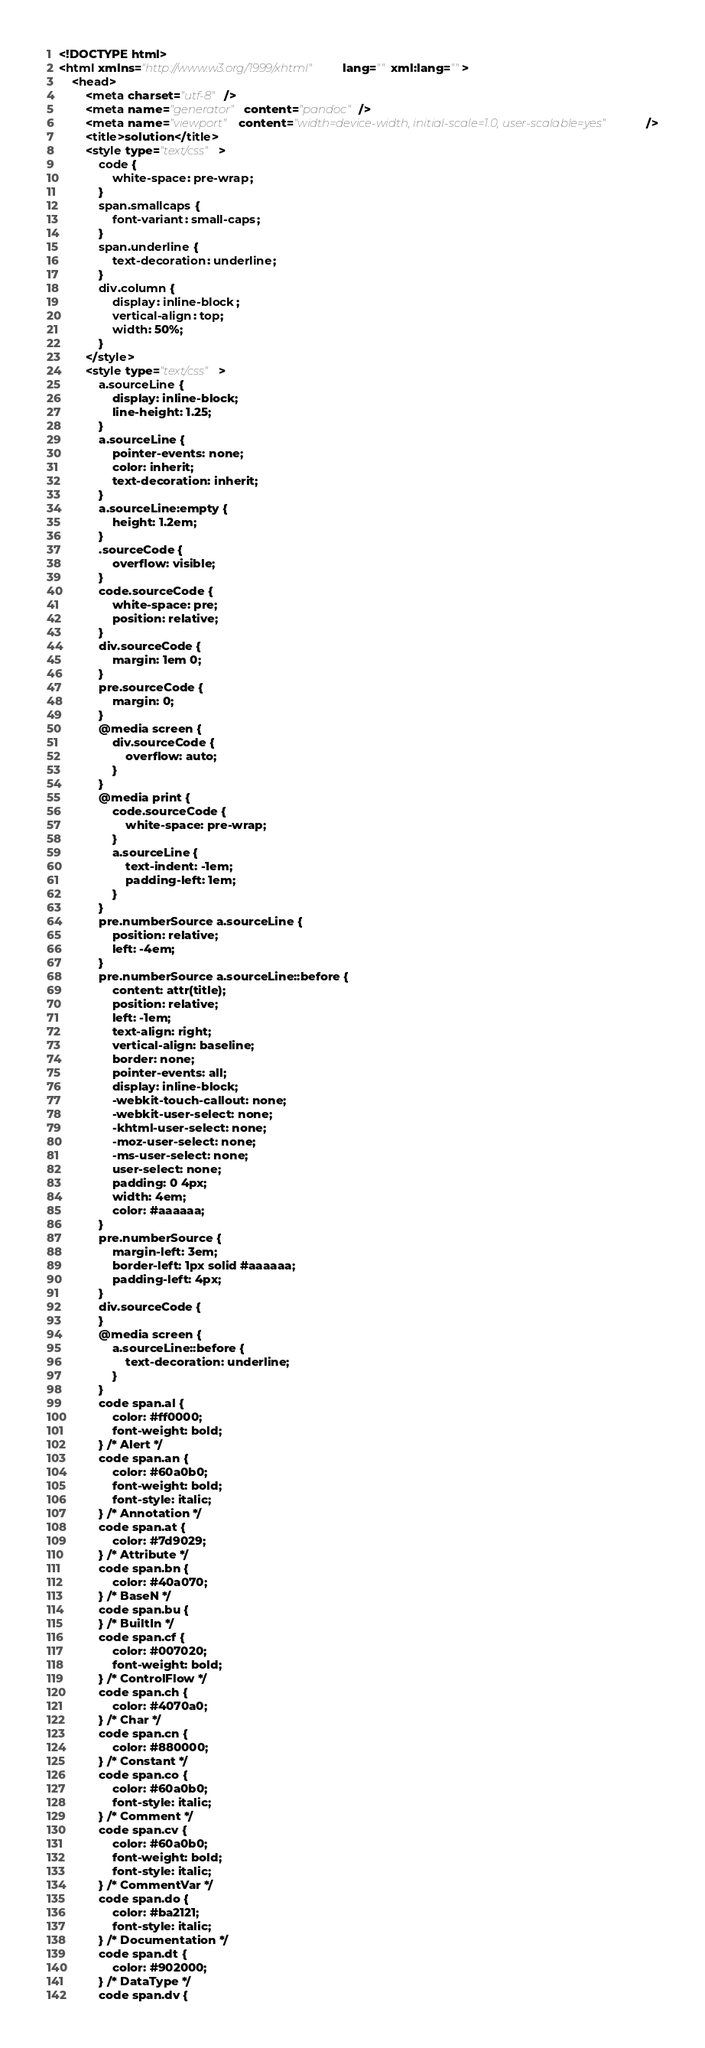<code> <loc_0><loc_0><loc_500><loc_500><_HTML_><!DOCTYPE html>
<html xmlns="http://www.w3.org/1999/xhtml" lang="" xml:lang="">
    <head>
        <meta charset="utf-8" />
        <meta name="generator" content="pandoc" />
        <meta name="viewport" content="width=device-width, initial-scale=1.0, user-scalable=yes" />
        <title>solution</title>
        <style type="text/css">
            code {
                white-space: pre-wrap;
            }
            span.smallcaps {
                font-variant: small-caps;
            }
            span.underline {
                text-decoration: underline;
            }
            div.column {
                display: inline-block;
                vertical-align: top;
                width: 50%;
            }
        </style>
        <style type="text/css">
            a.sourceLine {
                display: inline-block;
                line-height: 1.25;
            }
            a.sourceLine {
                pointer-events: none;
                color: inherit;
                text-decoration: inherit;
            }
            a.sourceLine:empty {
                height: 1.2em;
            }
            .sourceCode {
                overflow: visible;
            }
            code.sourceCode {
                white-space: pre;
                position: relative;
            }
            div.sourceCode {
                margin: 1em 0;
            }
            pre.sourceCode {
                margin: 0;
            }
            @media screen {
                div.sourceCode {
                    overflow: auto;
                }
            }
            @media print {
                code.sourceCode {
                    white-space: pre-wrap;
                }
                a.sourceLine {
                    text-indent: -1em;
                    padding-left: 1em;
                }
            }
            pre.numberSource a.sourceLine {
                position: relative;
                left: -4em;
            }
            pre.numberSource a.sourceLine::before {
                content: attr(title);
                position: relative;
                left: -1em;
                text-align: right;
                vertical-align: baseline;
                border: none;
                pointer-events: all;
                display: inline-block;
                -webkit-touch-callout: none;
                -webkit-user-select: none;
                -khtml-user-select: none;
                -moz-user-select: none;
                -ms-user-select: none;
                user-select: none;
                padding: 0 4px;
                width: 4em;
                color: #aaaaaa;
            }
            pre.numberSource {
                margin-left: 3em;
                border-left: 1px solid #aaaaaa;
                padding-left: 4px;
            }
            div.sourceCode {
            }
            @media screen {
                a.sourceLine::before {
                    text-decoration: underline;
                }
            }
            code span.al {
                color: #ff0000;
                font-weight: bold;
            } /* Alert */
            code span.an {
                color: #60a0b0;
                font-weight: bold;
                font-style: italic;
            } /* Annotation */
            code span.at {
                color: #7d9029;
            } /* Attribute */
            code span.bn {
                color: #40a070;
            } /* BaseN */
            code span.bu {
            } /* BuiltIn */
            code span.cf {
                color: #007020;
                font-weight: bold;
            } /* ControlFlow */
            code span.ch {
                color: #4070a0;
            } /* Char */
            code span.cn {
                color: #880000;
            } /* Constant */
            code span.co {
                color: #60a0b0;
                font-style: italic;
            } /* Comment */
            code span.cv {
                color: #60a0b0;
                font-weight: bold;
                font-style: italic;
            } /* CommentVar */
            code span.do {
                color: #ba2121;
                font-style: italic;
            } /* Documentation */
            code span.dt {
                color: #902000;
            } /* DataType */
            code span.dv {</code> 